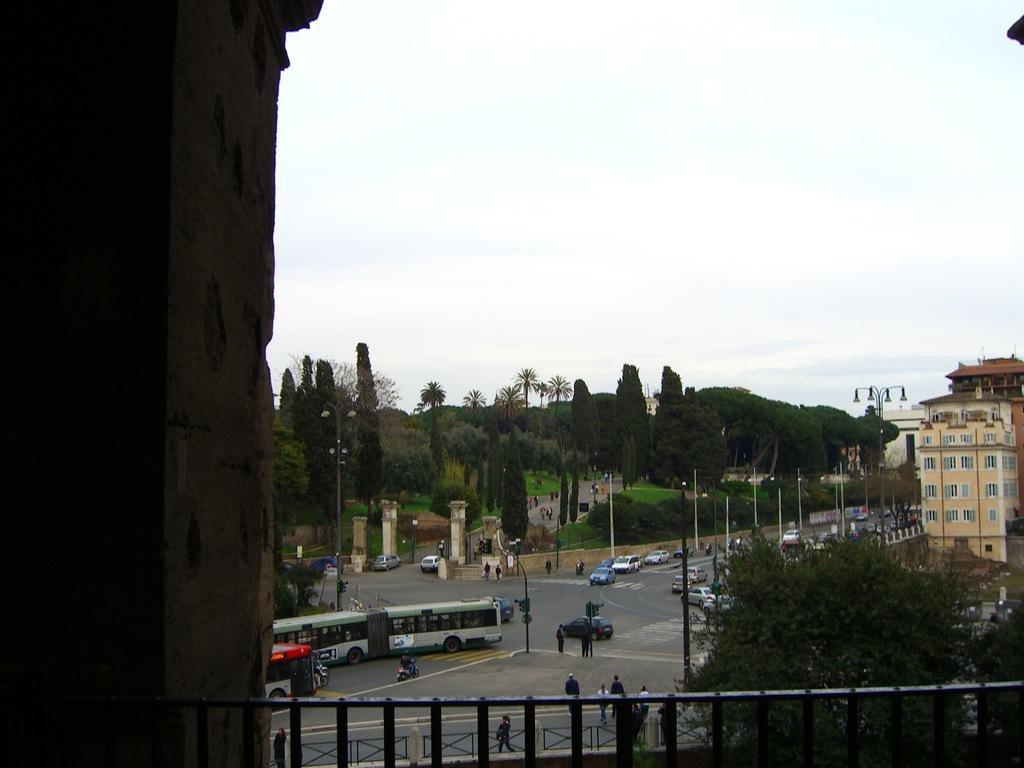Could you give a brief overview of what you see in this image? In this image we can see railings, trees, poles, pillars, grass, buildings, and people. There are vehicles on the road. In the background there is sky. 